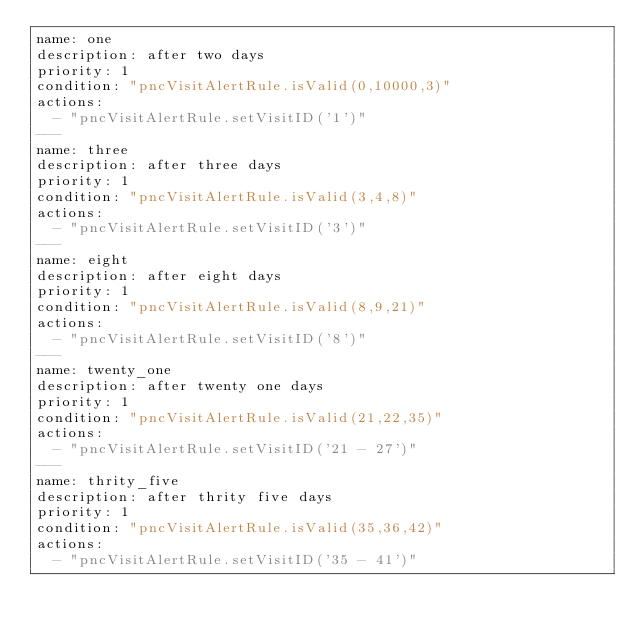<code> <loc_0><loc_0><loc_500><loc_500><_YAML_>name: one
description: after two days
priority: 1
condition: "pncVisitAlertRule.isValid(0,10000,3)"
actions:
  - "pncVisitAlertRule.setVisitID('1')"
---
name: three
description: after three days
priority: 1
condition: "pncVisitAlertRule.isValid(3,4,8)"
actions:
  - "pncVisitAlertRule.setVisitID('3')"
---
name: eight
description: after eight days
priority: 1
condition: "pncVisitAlertRule.isValid(8,9,21)"
actions:
  - "pncVisitAlertRule.setVisitID('8')"
---
name: twenty_one
description: after twenty one days
priority: 1
condition: "pncVisitAlertRule.isValid(21,22,35)"
actions:
  - "pncVisitAlertRule.setVisitID('21 - 27')"
---
name: thrity_five
description: after thrity five days
priority: 1
condition: "pncVisitAlertRule.isValid(35,36,42)"
actions:
  - "pncVisitAlertRule.setVisitID('35 - 41')"
</code> 